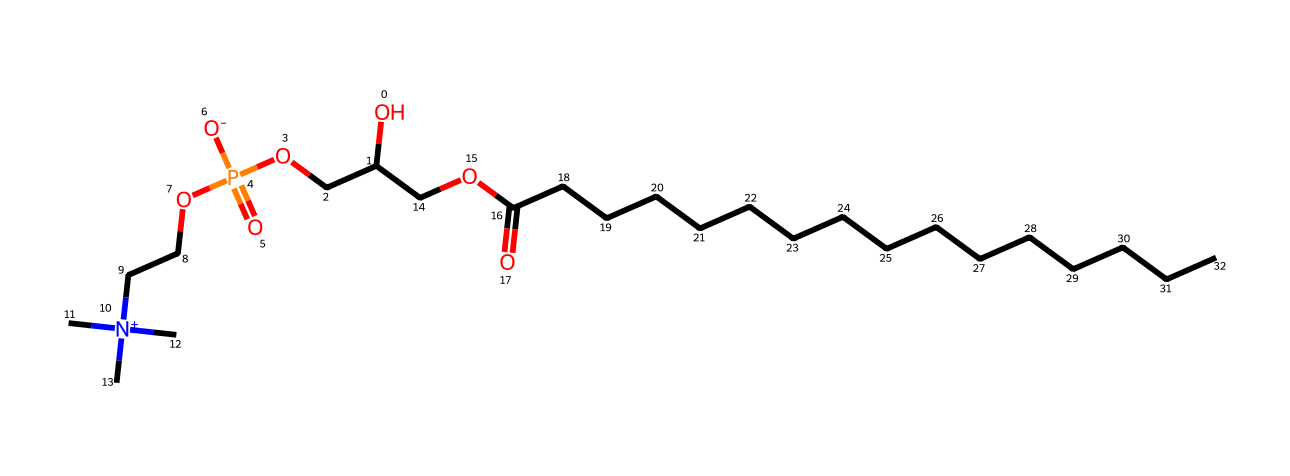What is the main functional group present in this compound? The compound contains a phosphate group, which is identifiable by the presence of phosphorus atom double-bonded to an oxygen atom and associated with several hydroxyl and alkyl groups.
Answer: phosphate How many carbon atoms are present in the molecule? By inspecting the SMILES, we can count the carbon atoms represented in the alkyl chains and the other structural components. There are 18 carbon atoms indicated in the structure.
Answer: 18 What is the charge of the nitrogen atom in the structure? The nitrogen atom in the compound is quaternary, as indicated by its connectivity to four carbon atoms and a positive charge; thus, its overall charge is positive.
Answer: positive What type of bond connects the phosphorus atom to the oxygen atoms? The phosphorus atom is primarily connected to the oxygen atoms through covalent bonds, as indicated by the connectivity in the chemical structure.
Answer: covalent How many oxygen atoms are found in this molecule? Counting the oxygen atoms in the region where the phosphate group is located, as well as the hydroxyl groups and carbonyl groups present gives a total of 5 oxygen atoms.
Answer: 5 What role does phosphatidylcholine play in cell membranes? Phosphatidylcholine serves as a phospholipid that is essential for membrane structure and function, contributing to the bilayer formation in cell membranes.
Answer: phospholipid Which atom in the structure suggests it has a nootropic effect? The presence of the nitrogen atom in a quaternary form is characteristic of compounds that can enhance cognitive function, linking it to potential nootropic effects.
Answer: nitrogen 